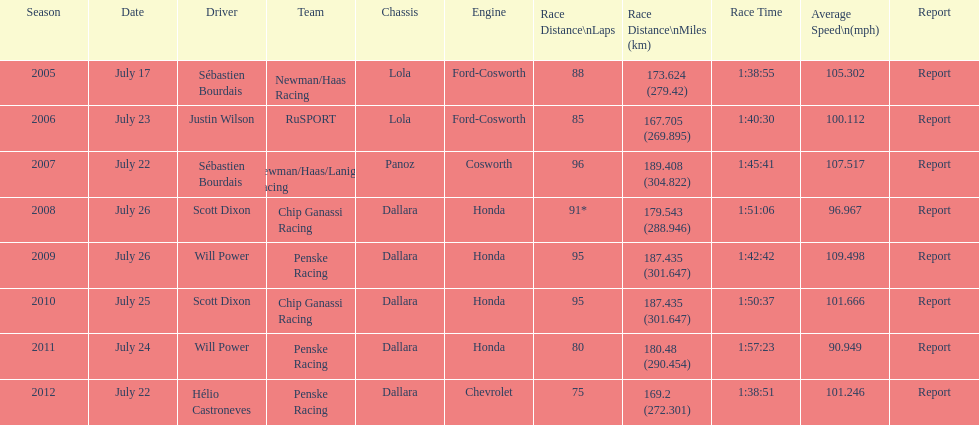Apart from france's flag (the first one), what is the count of flags displayed? 3. 